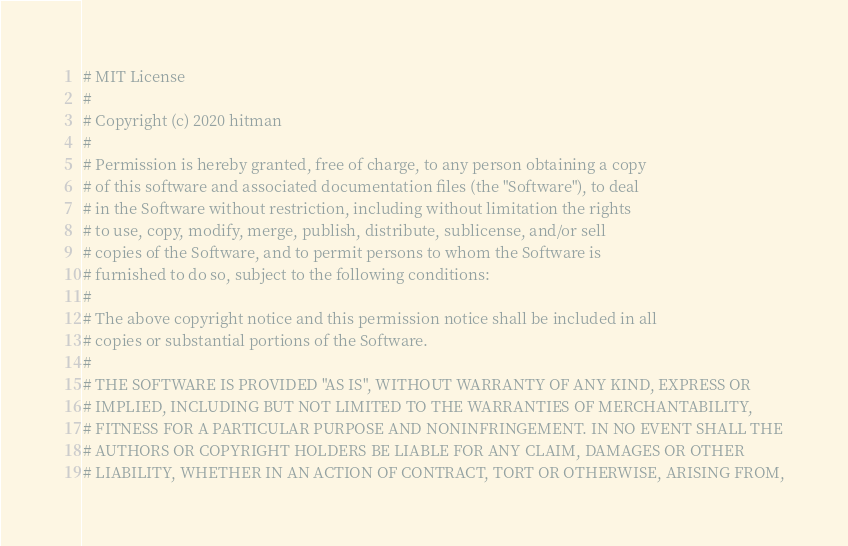<code> <loc_0><loc_0><loc_500><loc_500><_Python_># MIT License
#
# Copyright (c) 2020 hitman
#
# Permission is hereby granted, free of charge, to any person obtaining a copy
# of this software and associated documentation files (the "Software"), to deal
# in the Software without restriction, including without limitation the rights
# to use, copy, modify, merge, publish, distribute, sublicense, and/or sell
# copies of the Software, and to permit persons to whom the Software is
# furnished to do so, subject to the following conditions:
#
# The above copyright notice and this permission notice shall be included in all
# copies or substantial portions of the Software.
#
# THE SOFTWARE IS PROVIDED "AS IS", WITHOUT WARRANTY OF ANY KIND, EXPRESS OR
# IMPLIED, INCLUDING BUT NOT LIMITED TO THE WARRANTIES OF MERCHANTABILITY,
# FITNESS FOR A PARTICULAR PURPOSE AND NONINFRINGEMENT. IN NO EVENT SHALL THE
# AUTHORS OR COPYRIGHT HOLDERS BE LIABLE FOR ANY CLAIM, DAMAGES OR OTHER
# LIABILITY, WHETHER IN AN ACTION OF CONTRACT, TORT OR OTHERWISE, ARISING FROM,</code> 